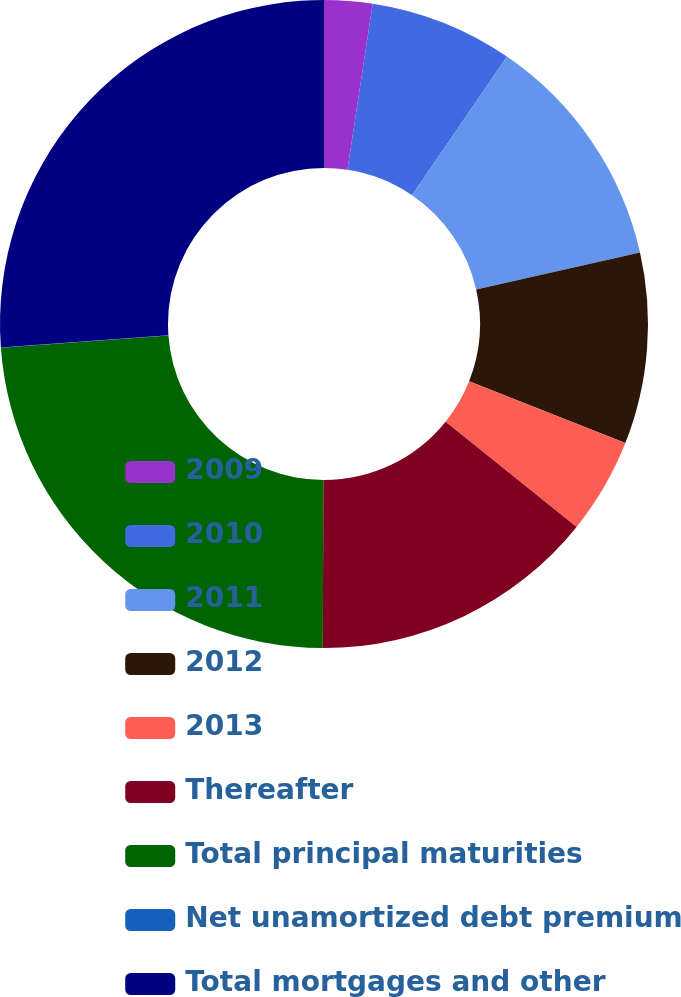Convert chart to OTSL. <chart><loc_0><loc_0><loc_500><loc_500><pie_chart><fcel>2009<fcel>2010<fcel>2011<fcel>2012<fcel>2013<fcel>Thereafter<fcel>Total principal maturities<fcel>Net unamortized debt premium<fcel>Total mortgages and other<nl><fcel>2.4%<fcel>7.15%<fcel>11.91%<fcel>9.53%<fcel>4.78%<fcel>14.29%<fcel>23.77%<fcel>0.02%<fcel>26.15%<nl></chart> 